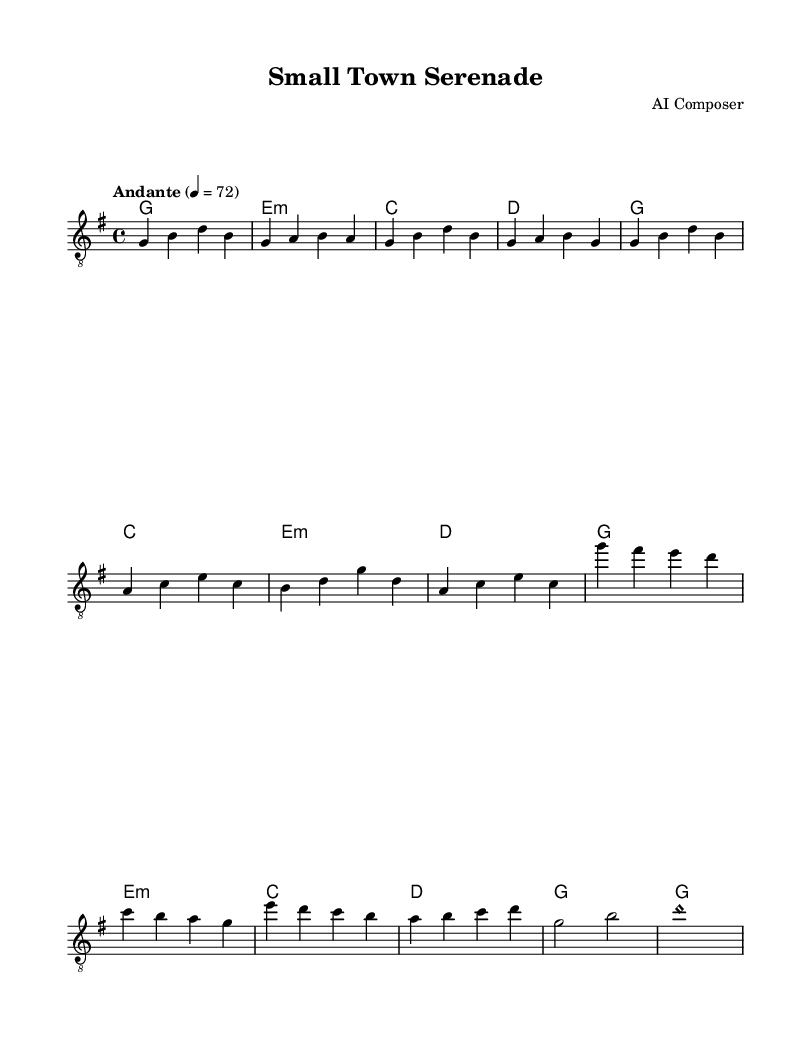What is the key signature of this music? The key signature is indicated at the beginning of the staff that shows one sharp, which corresponds to G major.
Answer: G major What is the time signature of this music? The time signature is clearly marked at the beginning of the score, showing four beats per measure.
Answer: 4/4 What is the tempo marking of this piece? The tempo marking is stated in words at the beginning of the score, specifying the speed as Andante, which corresponds to a moderate pace.
Answer: Andante How many measures are in the verse section? Counting the measures in the verse section, there are four measures, as visually identified from the notation.
Answer: 4 What is the first chord played in the intro? The first chord is denoted at the start of the score under the guitar section, showing it as G major.
Answer: G What is the last note played in the guitar part? The last note is indicated in the score, which shows the final note as a harmonic D.
Answer: Harmonic D Which musical section follows the intro? The next section is specified in the score immediately after the intro, labeled as the verse section.
Answer: Verse 